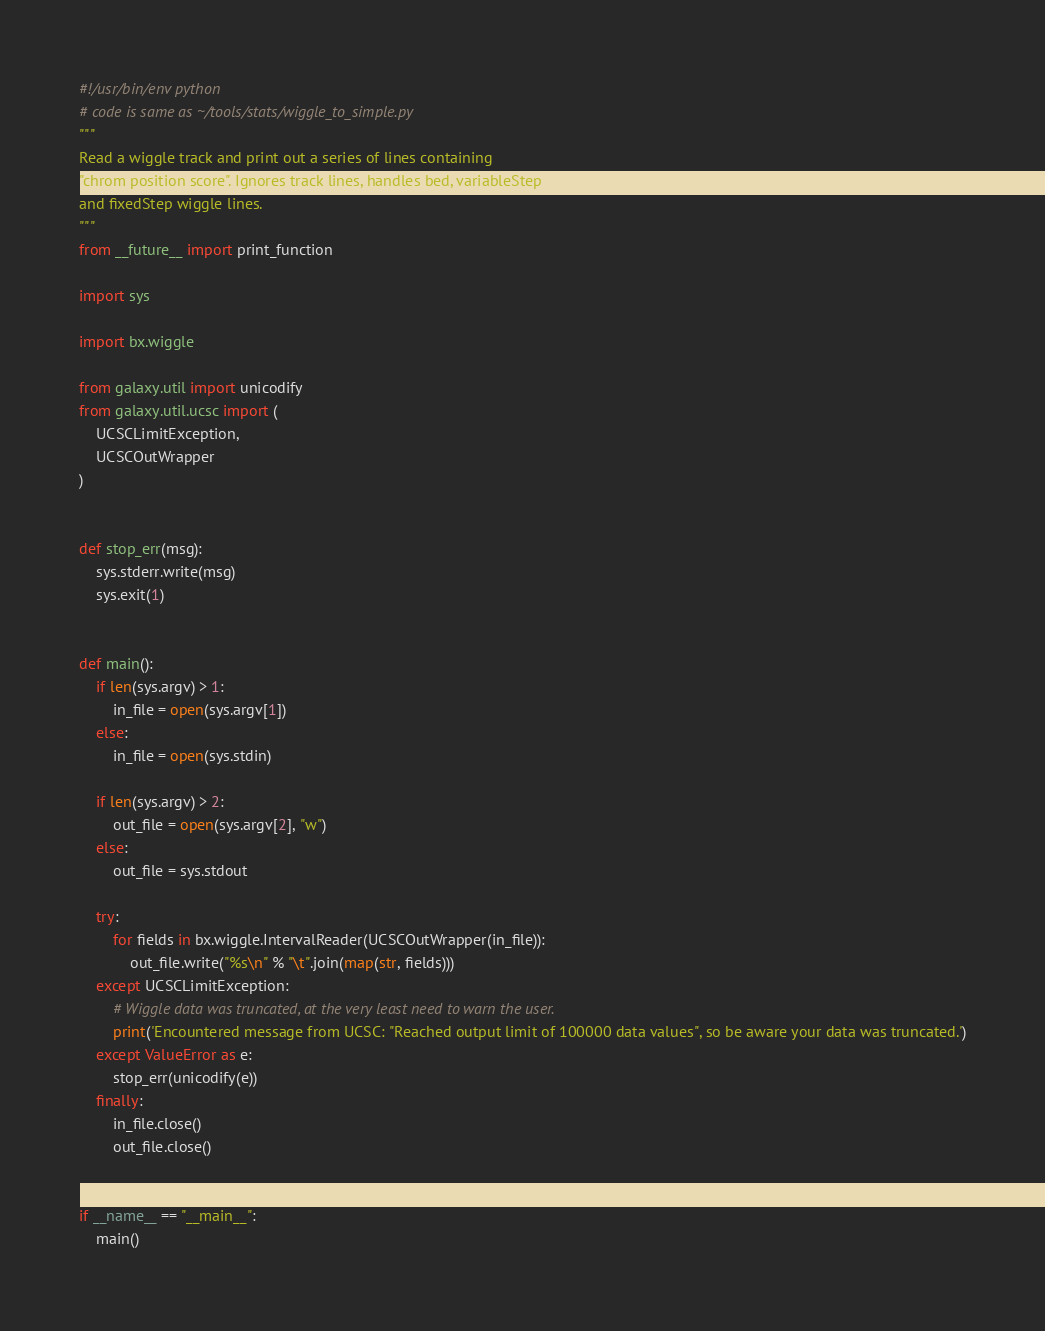<code> <loc_0><loc_0><loc_500><loc_500><_Python_>#!/usr/bin/env python
# code is same as ~/tools/stats/wiggle_to_simple.py
"""
Read a wiggle track and print out a series of lines containing
"chrom position score". Ignores track lines, handles bed, variableStep
and fixedStep wiggle lines.
"""
from __future__ import print_function

import sys

import bx.wiggle

from galaxy.util import unicodify
from galaxy.util.ucsc import (
    UCSCLimitException,
    UCSCOutWrapper
)


def stop_err(msg):
    sys.stderr.write(msg)
    sys.exit(1)


def main():
    if len(sys.argv) > 1:
        in_file = open(sys.argv[1])
    else:
        in_file = open(sys.stdin)

    if len(sys.argv) > 2:
        out_file = open(sys.argv[2], "w")
    else:
        out_file = sys.stdout

    try:
        for fields in bx.wiggle.IntervalReader(UCSCOutWrapper(in_file)):
            out_file.write("%s\n" % "\t".join(map(str, fields)))
    except UCSCLimitException:
        # Wiggle data was truncated, at the very least need to warn the user.
        print('Encountered message from UCSC: "Reached output limit of 100000 data values", so be aware your data was truncated.')
    except ValueError as e:
        stop_err(unicodify(e))
    finally:
        in_file.close()
        out_file.close()


if __name__ == "__main__":
    main()
</code> 